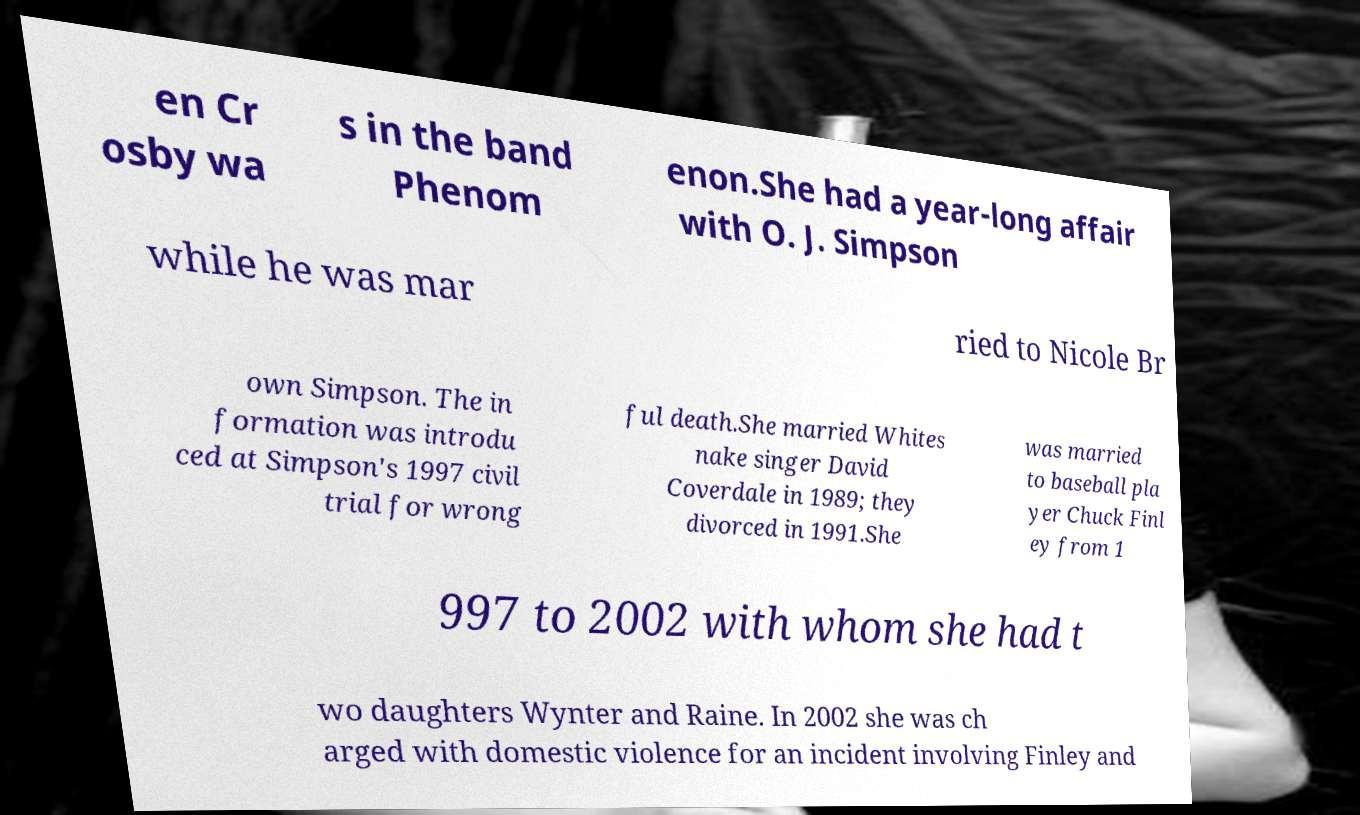Please identify and transcribe the text found in this image. en Cr osby wa s in the band Phenom enon.She had a year-long affair with O. J. Simpson while he was mar ried to Nicole Br own Simpson. The in formation was introdu ced at Simpson's 1997 civil trial for wrong ful death.She married Whites nake singer David Coverdale in 1989; they divorced in 1991.She was married to baseball pla yer Chuck Finl ey from 1 997 to 2002 with whom she had t wo daughters Wynter and Raine. In 2002 she was ch arged with domestic violence for an incident involving Finley and 